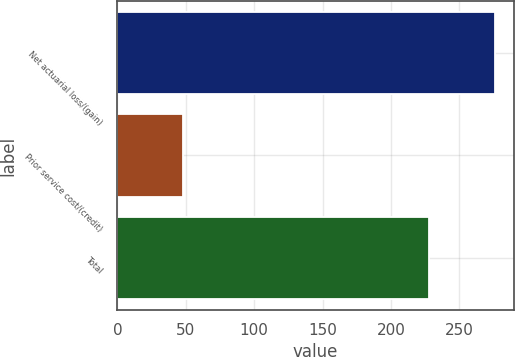Convert chart. <chart><loc_0><loc_0><loc_500><loc_500><bar_chart><fcel>Net actuarial loss/(gain)<fcel>Prior service cost/(credit)<fcel>Total<nl><fcel>276<fcel>48<fcel>228<nl></chart> 